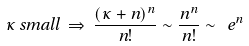Convert formula to latex. <formula><loc_0><loc_0><loc_500><loc_500>\kappa \, s m a l l \, \Rightarrow \, \frac { ( \kappa + n ) ^ { n } } { n ! } \sim \frac { n ^ { n } } { n ! } \sim \ e ^ { n }</formula> 